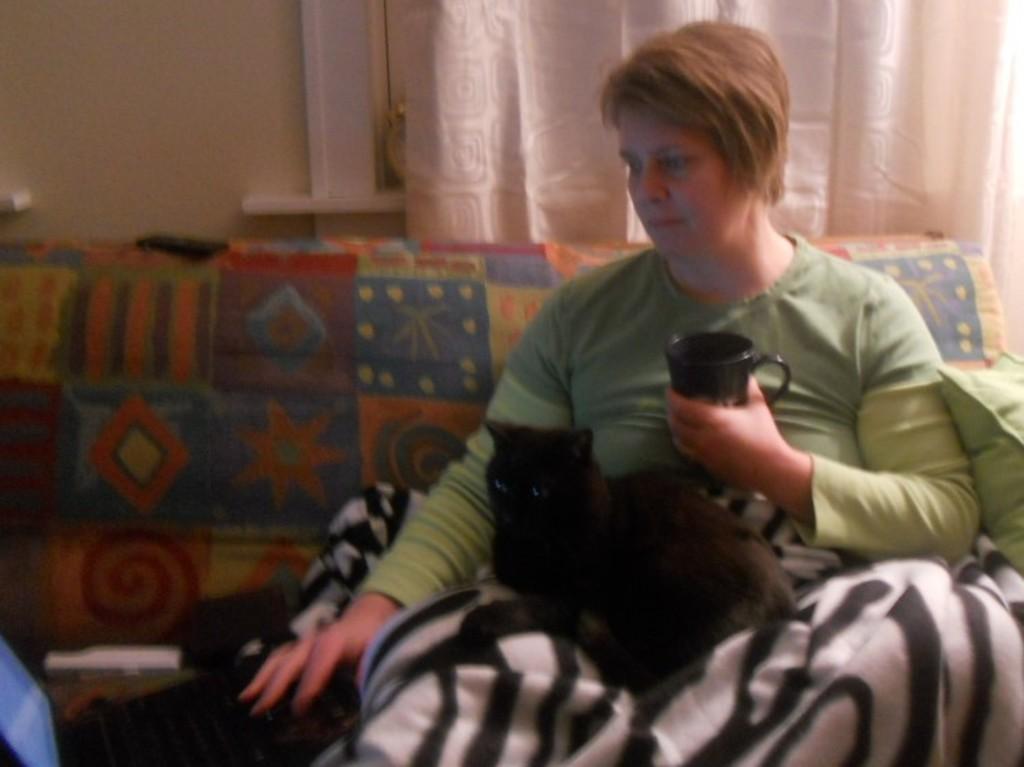How would you summarize this image in a sentence or two? This person is sitting on the couch and holding a black mug. On this person legs there is a blanket and black cat. Background we can see wall and curtain. Here we can see a pillow and remote.   